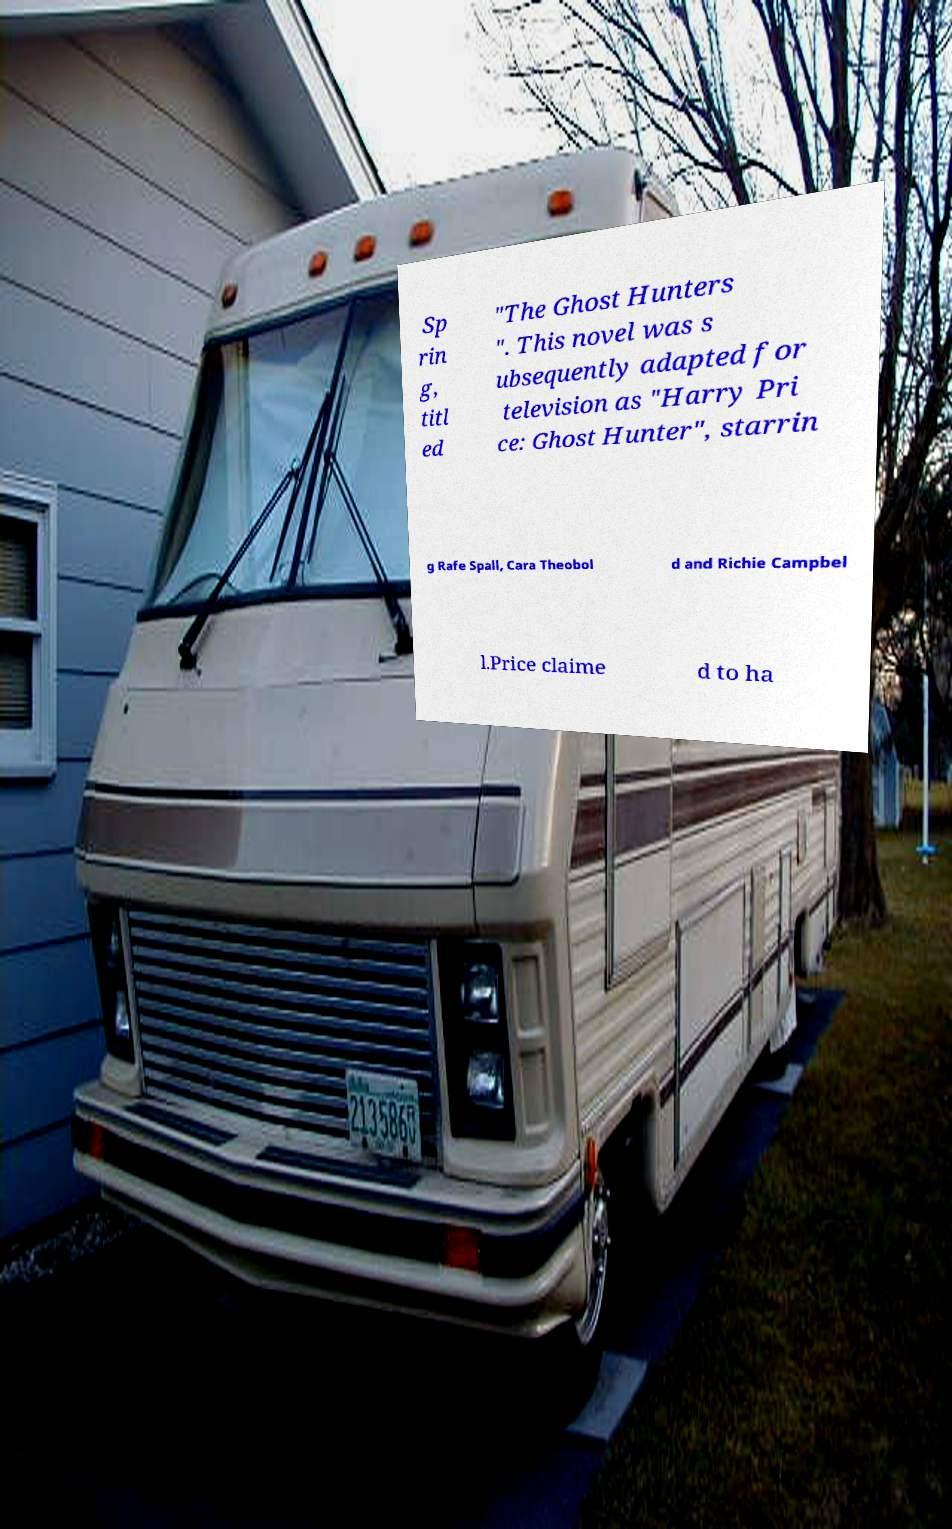Please identify and transcribe the text found in this image. Sp rin g, titl ed "The Ghost Hunters ". This novel was s ubsequently adapted for television as "Harry Pri ce: Ghost Hunter", starrin g Rafe Spall, Cara Theobol d and Richie Campbel l.Price claime d to ha 